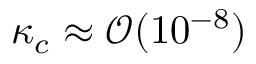<formula> <loc_0><loc_0><loc_500><loc_500>\kappa _ { c } \approx \mathcal { O } ( 1 0 ^ { - 8 } )</formula> 